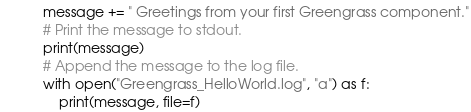Convert code to text. <code><loc_0><loc_0><loc_500><loc_500><_Python_>message += " Greetings from your first Greengrass component."
# Print the message to stdout.
print(message)
# Append the message to the log file.
with open("Greengrass_HelloWorld.log", "a") as f:
    print(message, file=f)
</code> 